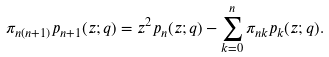Convert formula to latex. <formula><loc_0><loc_0><loc_500><loc_500>\pi _ { n ( n + 1 ) } p _ { n + 1 } ( z ; q ) = z ^ { 2 } p _ { n } ( z ; q ) - \sum _ { k = 0 } ^ { n } \pi _ { n k } p _ { k } ( z ; q ) .</formula> 